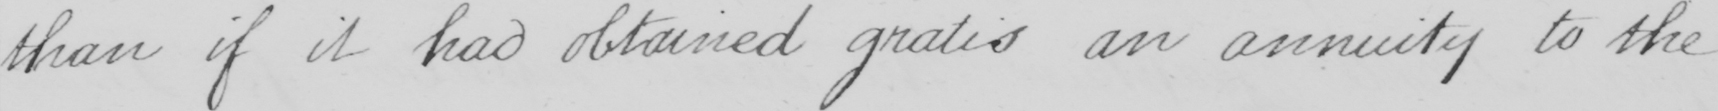What does this handwritten line say? than if it had obtained gratis an annuity to the 